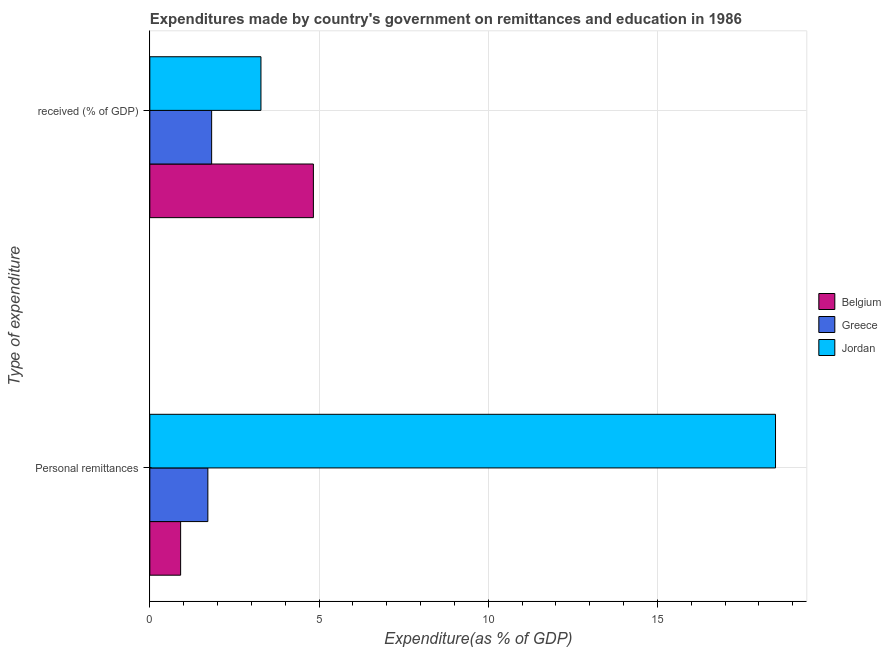How many different coloured bars are there?
Your answer should be very brief. 3. How many groups of bars are there?
Keep it short and to the point. 2. Are the number of bars per tick equal to the number of legend labels?
Provide a succinct answer. Yes. Are the number of bars on each tick of the Y-axis equal?
Keep it short and to the point. Yes. What is the label of the 2nd group of bars from the top?
Offer a very short reply. Personal remittances. What is the expenditure in education in Jordan?
Give a very brief answer. 3.28. Across all countries, what is the maximum expenditure in education?
Provide a short and direct response. 4.83. Across all countries, what is the minimum expenditure in personal remittances?
Your answer should be compact. 0.91. In which country was the expenditure in personal remittances minimum?
Your answer should be compact. Belgium. What is the total expenditure in personal remittances in the graph?
Your response must be concise. 21.12. What is the difference between the expenditure in education in Belgium and that in Greece?
Offer a terse response. 3.01. What is the difference between the expenditure in personal remittances in Jordan and the expenditure in education in Belgium?
Offer a terse response. 13.66. What is the average expenditure in personal remittances per country?
Offer a very short reply. 7.04. What is the difference between the expenditure in personal remittances and expenditure in education in Belgium?
Make the answer very short. -3.92. What is the ratio of the expenditure in education in Jordan to that in Greece?
Your answer should be very brief. 1.8. Is the expenditure in personal remittances in Belgium less than that in Greece?
Your answer should be very brief. Yes. In how many countries, is the expenditure in education greater than the average expenditure in education taken over all countries?
Make the answer very short. 1. What does the 2nd bar from the bottom in Personal remittances represents?
Make the answer very short. Greece. How many bars are there?
Offer a terse response. 6. Are all the bars in the graph horizontal?
Provide a succinct answer. Yes. How many countries are there in the graph?
Your answer should be compact. 3. Does the graph contain any zero values?
Provide a short and direct response. No. Does the graph contain grids?
Provide a short and direct response. Yes. Where does the legend appear in the graph?
Offer a very short reply. Center right. How many legend labels are there?
Make the answer very short. 3. What is the title of the graph?
Keep it short and to the point. Expenditures made by country's government on remittances and education in 1986. Does "Azerbaijan" appear as one of the legend labels in the graph?
Ensure brevity in your answer.  No. What is the label or title of the X-axis?
Give a very brief answer. Expenditure(as % of GDP). What is the label or title of the Y-axis?
Keep it short and to the point. Type of expenditure. What is the Expenditure(as % of GDP) of Belgium in Personal remittances?
Provide a short and direct response. 0.91. What is the Expenditure(as % of GDP) of Greece in Personal remittances?
Offer a very short reply. 1.72. What is the Expenditure(as % of GDP) of Jordan in Personal remittances?
Your answer should be compact. 18.49. What is the Expenditure(as % of GDP) of Belgium in  received (% of GDP)?
Offer a very short reply. 4.83. What is the Expenditure(as % of GDP) of Greece in  received (% of GDP)?
Your answer should be very brief. 1.83. What is the Expenditure(as % of GDP) in Jordan in  received (% of GDP)?
Your answer should be very brief. 3.28. Across all Type of expenditure, what is the maximum Expenditure(as % of GDP) in Belgium?
Provide a short and direct response. 4.83. Across all Type of expenditure, what is the maximum Expenditure(as % of GDP) in Greece?
Ensure brevity in your answer.  1.83. Across all Type of expenditure, what is the maximum Expenditure(as % of GDP) of Jordan?
Offer a terse response. 18.49. Across all Type of expenditure, what is the minimum Expenditure(as % of GDP) in Belgium?
Ensure brevity in your answer.  0.91. Across all Type of expenditure, what is the minimum Expenditure(as % of GDP) in Greece?
Keep it short and to the point. 1.72. Across all Type of expenditure, what is the minimum Expenditure(as % of GDP) in Jordan?
Provide a succinct answer. 3.28. What is the total Expenditure(as % of GDP) of Belgium in the graph?
Make the answer very short. 5.74. What is the total Expenditure(as % of GDP) in Greece in the graph?
Offer a very short reply. 3.54. What is the total Expenditure(as % of GDP) of Jordan in the graph?
Offer a very short reply. 21.78. What is the difference between the Expenditure(as % of GDP) of Belgium in Personal remittances and that in  received (% of GDP)?
Your response must be concise. -3.92. What is the difference between the Expenditure(as % of GDP) of Greece in Personal remittances and that in  received (% of GDP)?
Provide a short and direct response. -0.11. What is the difference between the Expenditure(as % of GDP) in Jordan in Personal remittances and that in  received (% of GDP)?
Provide a succinct answer. 15.21. What is the difference between the Expenditure(as % of GDP) in Belgium in Personal remittances and the Expenditure(as % of GDP) in Greece in  received (% of GDP)?
Keep it short and to the point. -0.92. What is the difference between the Expenditure(as % of GDP) of Belgium in Personal remittances and the Expenditure(as % of GDP) of Jordan in  received (% of GDP)?
Your answer should be very brief. -2.37. What is the difference between the Expenditure(as % of GDP) of Greece in Personal remittances and the Expenditure(as % of GDP) of Jordan in  received (% of GDP)?
Your answer should be very brief. -1.57. What is the average Expenditure(as % of GDP) of Belgium per Type of expenditure?
Make the answer very short. 2.87. What is the average Expenditure(as % of GDP) in Greece per Type of expenditure?
Provide a short and direct response. 1.77. What is the average Expenditure(as % of GDP) of Jordan per Type of expenditure?
Give a very brief answer. 10.89. What is the difference between the Expenditure(as % of GDP) of Belgium and Expenditure(as % of GDP) of Greece in Personal remittances?
Provide a short and direct response. -0.8. What is the difference between the Expenditure(as % of GDP) of Belgium and Expenditure(as % of GDP) of Jordan in Personal remittances?
Offer a very short reply. -17.58. What is the difference between the Expenditure(as % of GDP) of Greece and Expenditure(as % of GDP) of Jordan in Personal remittances?
Keep it short and to the point. -16.78. What is the difference between the Expenditure(as % of GDP) in Belgium and Expenditure(as % of GDP) in Greece in  received (% of GDP)?
Make the answer very short. 3.01. What is the difference between the Expenditure(as % of GDP) of Belgium and Expenditure(as % of GDP) of Jordan in  received (% of GDP)?
Your answer should be compact. 1.55. What is the difference between the Expenditure(as % of GDP) in Greece and Expenditure(as % of GDP) in Jordan in  received (% of GDP)?
Offer a terse response. -1.46. What is the ratio of the Expenditure(as % of GDP) of Belgium in Personal remittances to that in  received (% of GDP)?
Your answer should be compact. 0.19. What is the ratio of the Expenditure(as % of GDP) of Greece in Personal remittances to that in  received (% of GDP)?
Your response must be concise. 0.94. What is the ratio of the Expenditure(as % of GDP) in Jordan in Personal remittances to that in  received (% of GDP)?
Your answer should be compact. 5.63. What is the difference between the highest and the second highest Expenditure(as % of GDP) of Belgium?
Offer a terse response. 3.92. What is the difference between the highest and the second highest Expenditure(as % of GDP) of Greece?
Your answer should be very brief. 0.11. What is the difference between the highest and the second highest Expenditure(as % of GDP) of Jordan?
Give a very brief answer. 15.21. What is the difference between the highest and the lowest Expenditure(as % of GDP) of Belgium?
Your answer should be very brief. 3.92. What is the difference between the highest and the lowest Expenditure(as % of GDP) in Greece?
Ensure brevity in your answer.  0.11. What is the difference between the highest and the lowest Expenditure(as % of GDP) in Jordan?
Offer a very short reply. 15.21. 